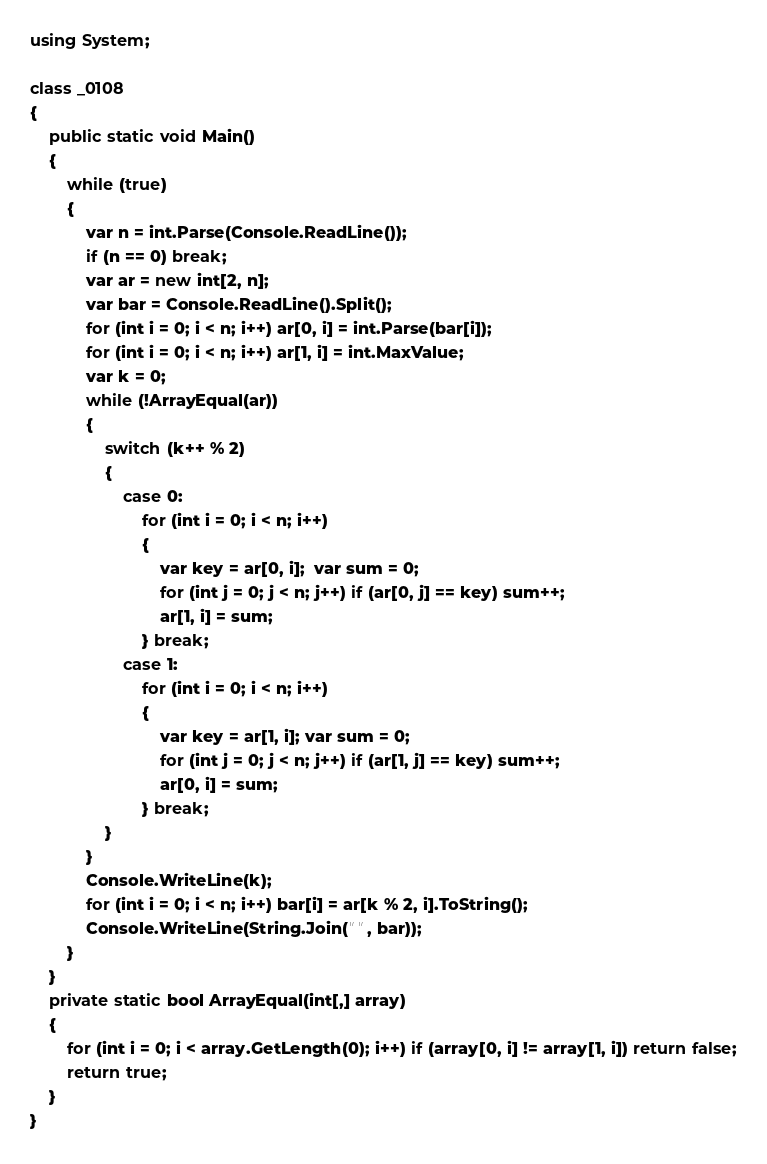Convert code to text. <code><loc_0><loc_0><loc_500><loc_500><_C#_>using System;

class _0108
{
    public static void Main()
    {
        while (true)
        {
            var n = int.Parse(Console.ReadLine());
            if (n == 0) break;
            var ar = new int[2, n];
            var bar = Console.ReadLine().Split();
            for (int i = 0; i < n; i++) ar[0, i] = int.Parse(bar[i]);
            for (int i = 0; i < n; i++) ar[1, i] = int.MaxValue;
            var k = 0;
            while (!ArrayEqual(ar))
            {
                switch (k++ % 2)
                {
                    case 0:
                        for (int i = 0; i < n; i++)
                        {
                            var key = ar[0, i];  var sum = 0;
                            for (int j = 0; j < n; j++) if (ar[0, j] == key) sum++;
                            ar[1, i] = sum;
                        } break;
                    case 1:
                        for (int i = 0; i < n; i++)
                        {
                            var key = ar[1, i]; var sum = 0;
                            for (int j = 0; j < n; j++) if (ar[1, j] == key) sum++;
                            ar[0, i] = sum;
                        } break;
                }
            }
            Console.WriteLine(k);
            for (int i = 0; i < n; i++) bar[i] = ar[k % 2, i].ToString();
            Console.WriteLine(String.Join(" ", bar));
        }
    }
    private static bool ArrayEqual(int[,] array)
    {
        for (int i = 0; i < array.GetLength(0); i++) if (array[0, i] != array[1, i]) return false;
        return true;
    }
}</code> 